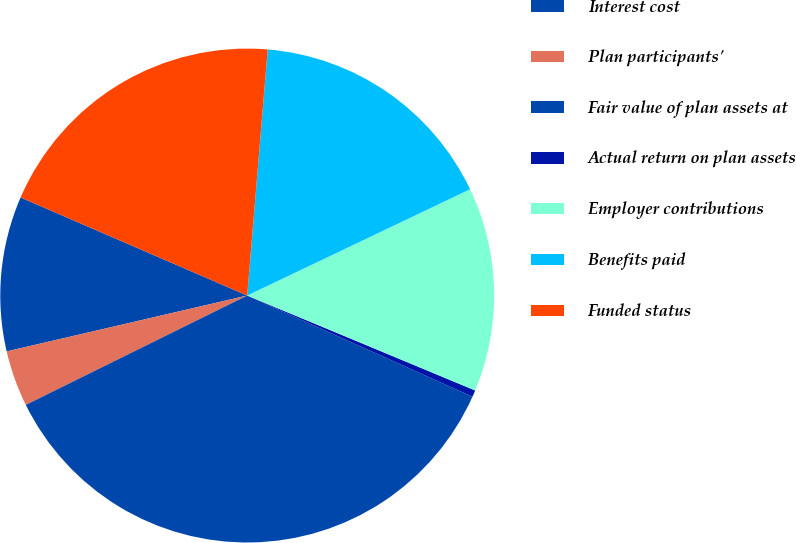<chart> <loc_0><loc_0><loc_500><loc_500><pie_chart><fcel>Interest cost<fcel>Plan participants'<fcel>Fair value of plan assets at<fcel>Actual return on plan assets<fcel>Employer contributions<fcel>Benefits paid<fcel>Funded status<nl><fcel>10.13%<fcel>3.67%<fcel>35.97%<fcel>0.44%<fcel>13.36%<fcel>16.59%<fcel>19.82%<nl></chart> 